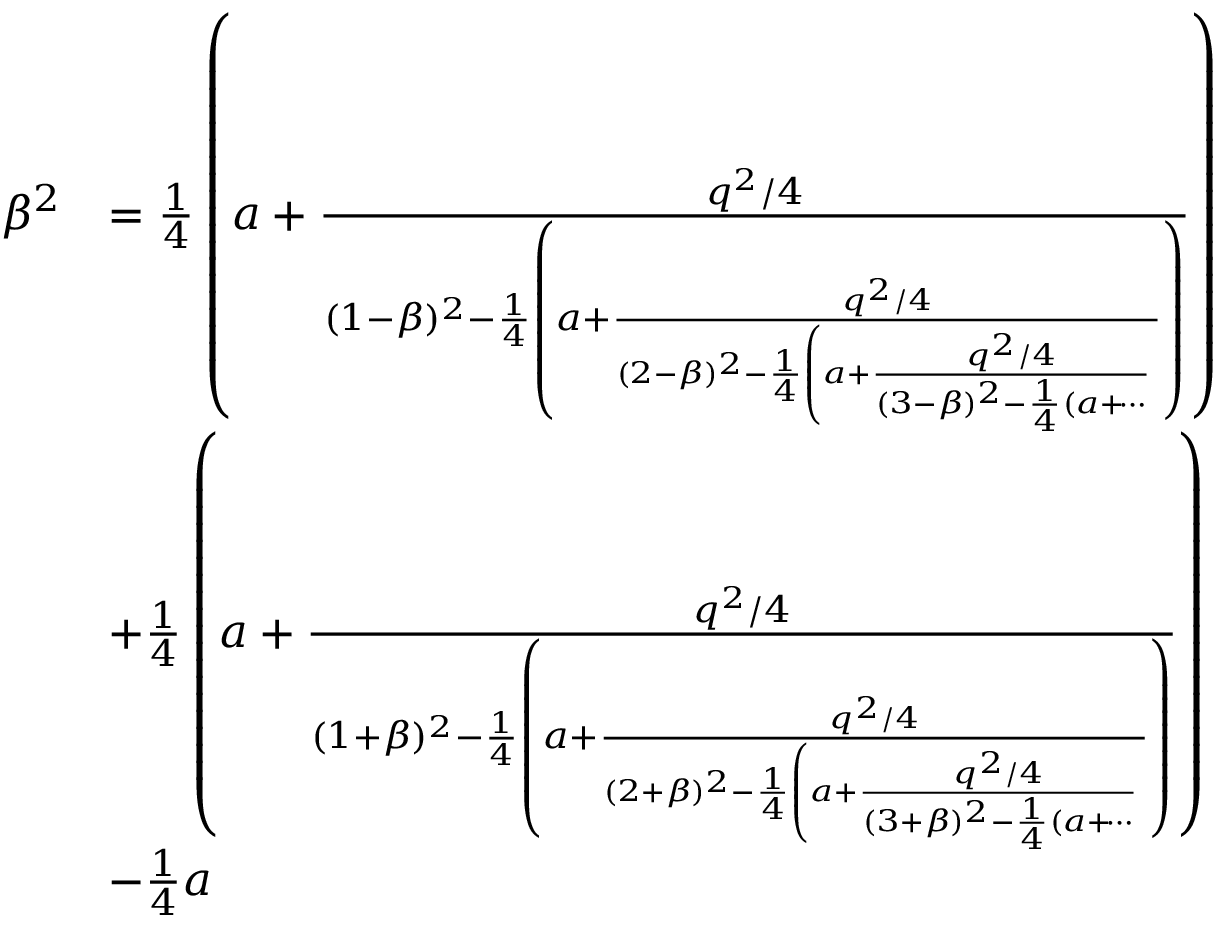Convert formula to latex. <formula><loc_0><loc_0><loc_500><loc_500>\begin{array} { r l } { \beta ^ { 2 } } & { = \frac { 1 } { 4 } \left ( a + \frac { q ^ { 2 } / 4 } { ( 1 - \beta ) ^ { 2 } - \frac { 1 } { 4 } \left ( a + \frac { q ^ { 2 } / 4 } { ( 2 - \beta ) ^ { 2 } - \frac { 1 } { 4 } \left ( a + \frac { q ^ { 2 } / 4 } { ( 3 - \beta ) ^ { 2 } - \frac { 1 } { 4 } ( a + \dots i } } \right ) } \right ) } \\ & { + \frac { 1 } { 4 } \left ( a + \frac { q ^ { 2 } / 4 } { ( 1 + \beta ) ^ { 2 } - \frac { 1 } { 4 } \left ( a + \frac { q ^ { 2 } / 4 } { ( 2 + \beta ) ^ { 2 } - \frac { 1 } { 4 } \left ( a + \frac { q ^ { 2 } / 4 } { ( 3 + \beta ) ^ { 2 } - \frac { 1 } { 4 } ( a + \dots i } } \right ) } \right ) } \\ & { - \frac { 1 } { 4 } a } \end{array}</formula> 